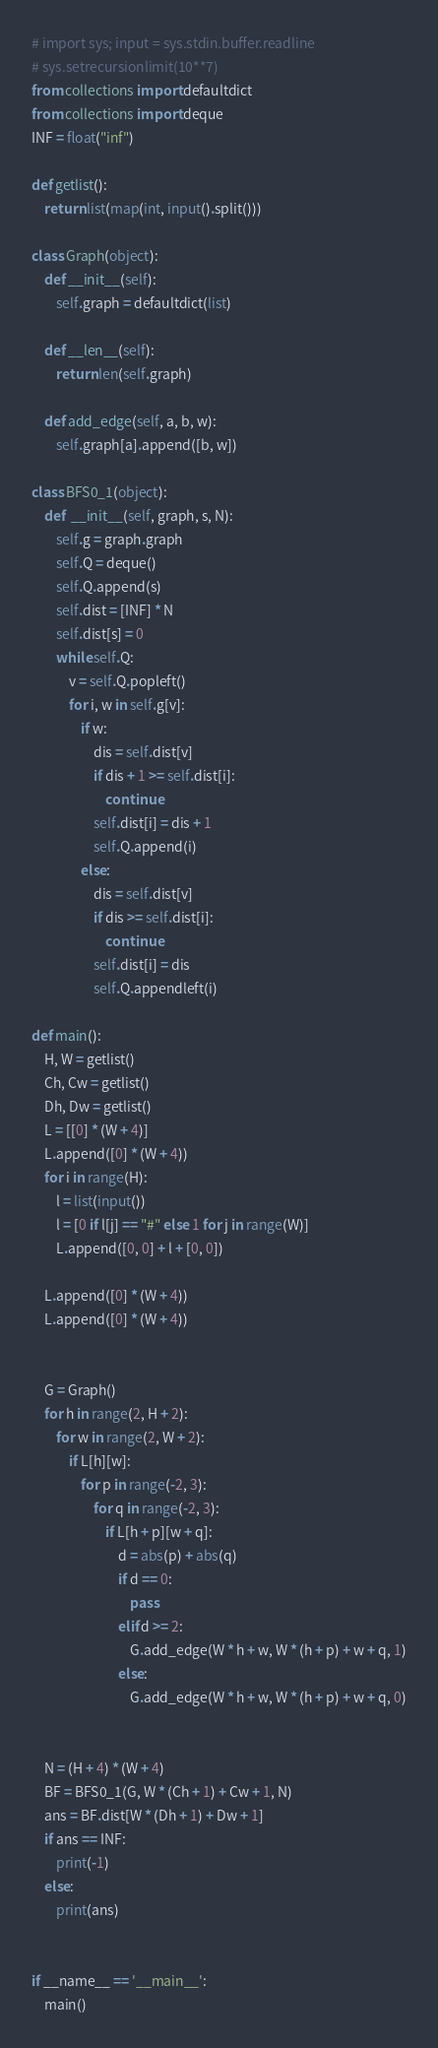Convert code to text. <code><loc_0><loc_0><loc_500><loc_500><_Python_># import sys; input = sys.stdin.buffer.readline
# sys.setrecursionlimit(10**7)
from collections import defaultdict
from collections import deque
INF = float("inf")

def getlist():
	return list(map(int, input().split()))

class Graph(object):
	def __init__(self):
		self.graph = defaultdict(list)

	def __len__(self):
		return len(self.graph)

	def add_edge(self, a, b, w):
		self.graph[a].append([b, w])

class BFS0_1(object):
	def  __init__(self, graph, s, N):
		self.g = graph.graph
		self.Q = deque()
		self.Q.append(s)
		self.dist = [INF] * N
		self.dist[s] = 0
		while self.Q:
			v = self.Q.popleft()
			for i, w in self.g[v]:
				if w:
					dis = self.dist[v]
					if dis + 1 >= self.dist[i]:
						continue
					self.dist[i] = dis + 1
					self.Q.append(i)
				else:
					dis = self.dist[v]
					if dis >= self.dist[i]:
						continue
					self.dist[i] = dis
					self.Q.appendleft(i)

def main():
	H, W = getlist()
	Ch, Cw = getlist()
	Dh, Dw = getlist()
	L = [[0] * (W + 4)]
	L.append([0] * (W + 4))
	for i in range(H):
		l = list(input())
		l = [0 if l[j] == "#" else 1 for j in range(W)]
		L.append([0, 0] + l + [0, 0])

	L.append([0] * (W + 4))
	L.append([0] * (W + 4))


	G = Graph()
	for h in range(2, H + 2):
		for w in range(2, W + 2):
			if L[h][w]:
				for p in range(-2, 3):
					for q in range(-2, 3):
						if L[h + p][w + q]:
							d = abs(p) + abs(q)
							if d == 0:
								pass
							elif d >= 2:
								G.add_edge(W * h + w, W * (h + p) + w + q, 1)
							else:
								G.add_edge(W * h + w, W * (h + p) + w + q, 0)


	N = (H + 4) * (W + 4)
	BF = BFS0_1(G, W * (Ch + 1) + Cw + 1, N)
	ans = BF.dist[W * (Dh + 1) + Dw + 1]
	if ans == INF:
		print(-1)
	else:
		print(ans)


if __name__ == '__main__':
	main()</code> 